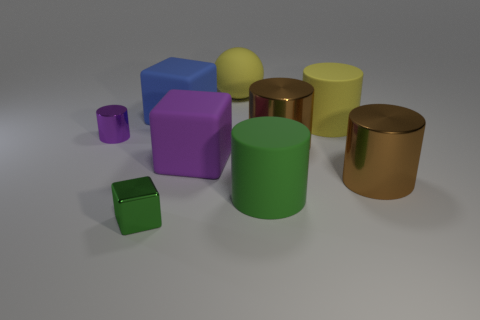Are there any objects that appear to be made of a different material than the others? Yes, the two cylinders look to have a metallic finish, which contrasts with the matte texture of the other geometric shapes, suggesting they are made of a different material. 